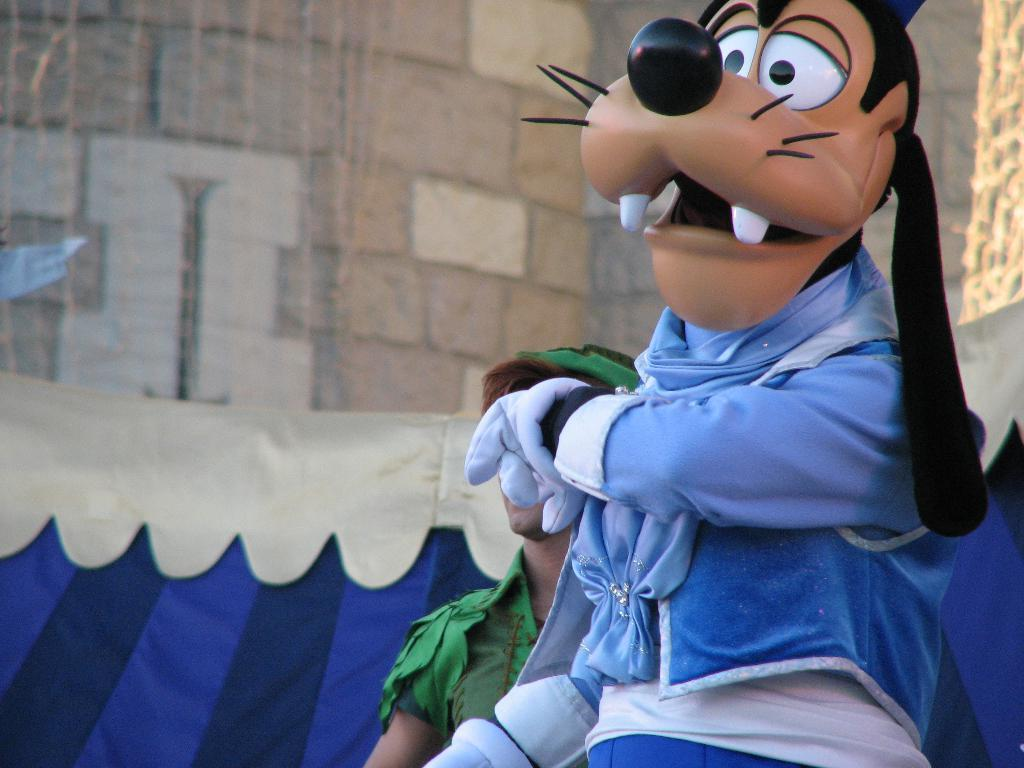What type of image is shown in the picture? The image contains a depiction of a cartoon. Can you describe the character in the cartoon? There is a person in the cartoon. What color is the cloth in the cartoon? There is a blue color cloth in the cartoon. What is visible in the background of the cartoon? There is a wall in the background of the cartoon. What type of current is flowing through the pail in the image? A: There is no pail present in the image, and therefore no current can be observed. 